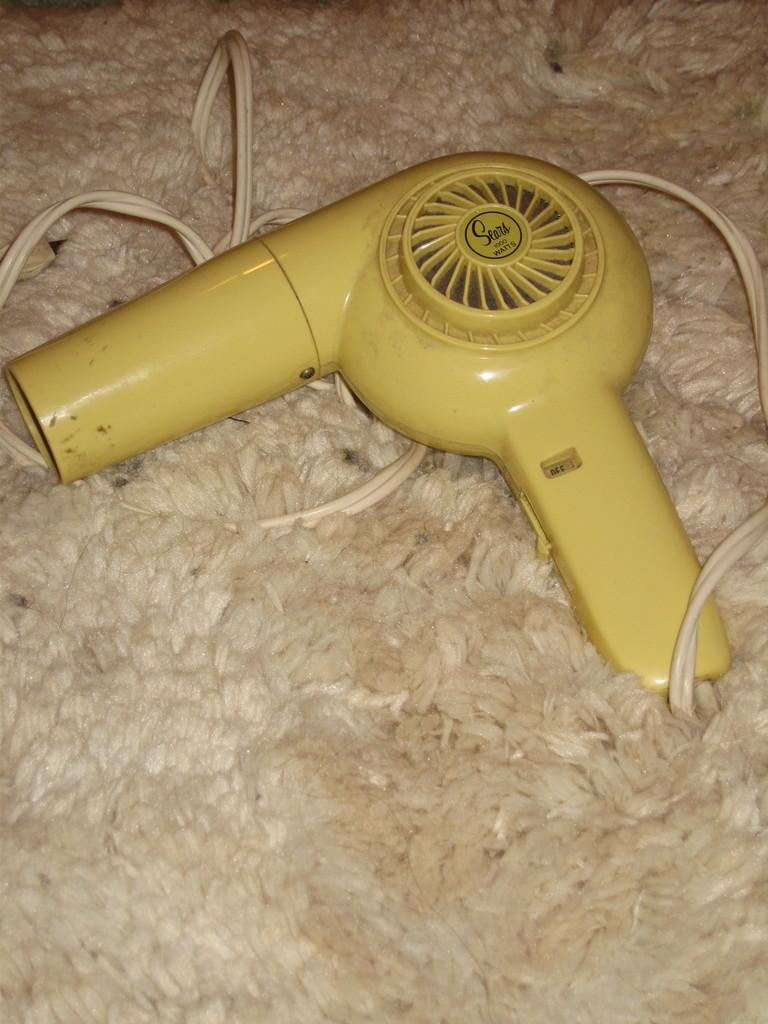What is present on the floor in the image? There is a mat in the image. What appliance can be seen in the image? There is a hair dryer machine in the image. What is attached to the hair dryer machine? The hair dryer machine has a wire. What color is the wire? The wire is white in color. What color is the hair dryer machine? The hair dryer machine is yellow in color. How many sheep are visible in the image? There are no sheep present in the image. What shape is the iron in the image? There is no iron present in the image. 